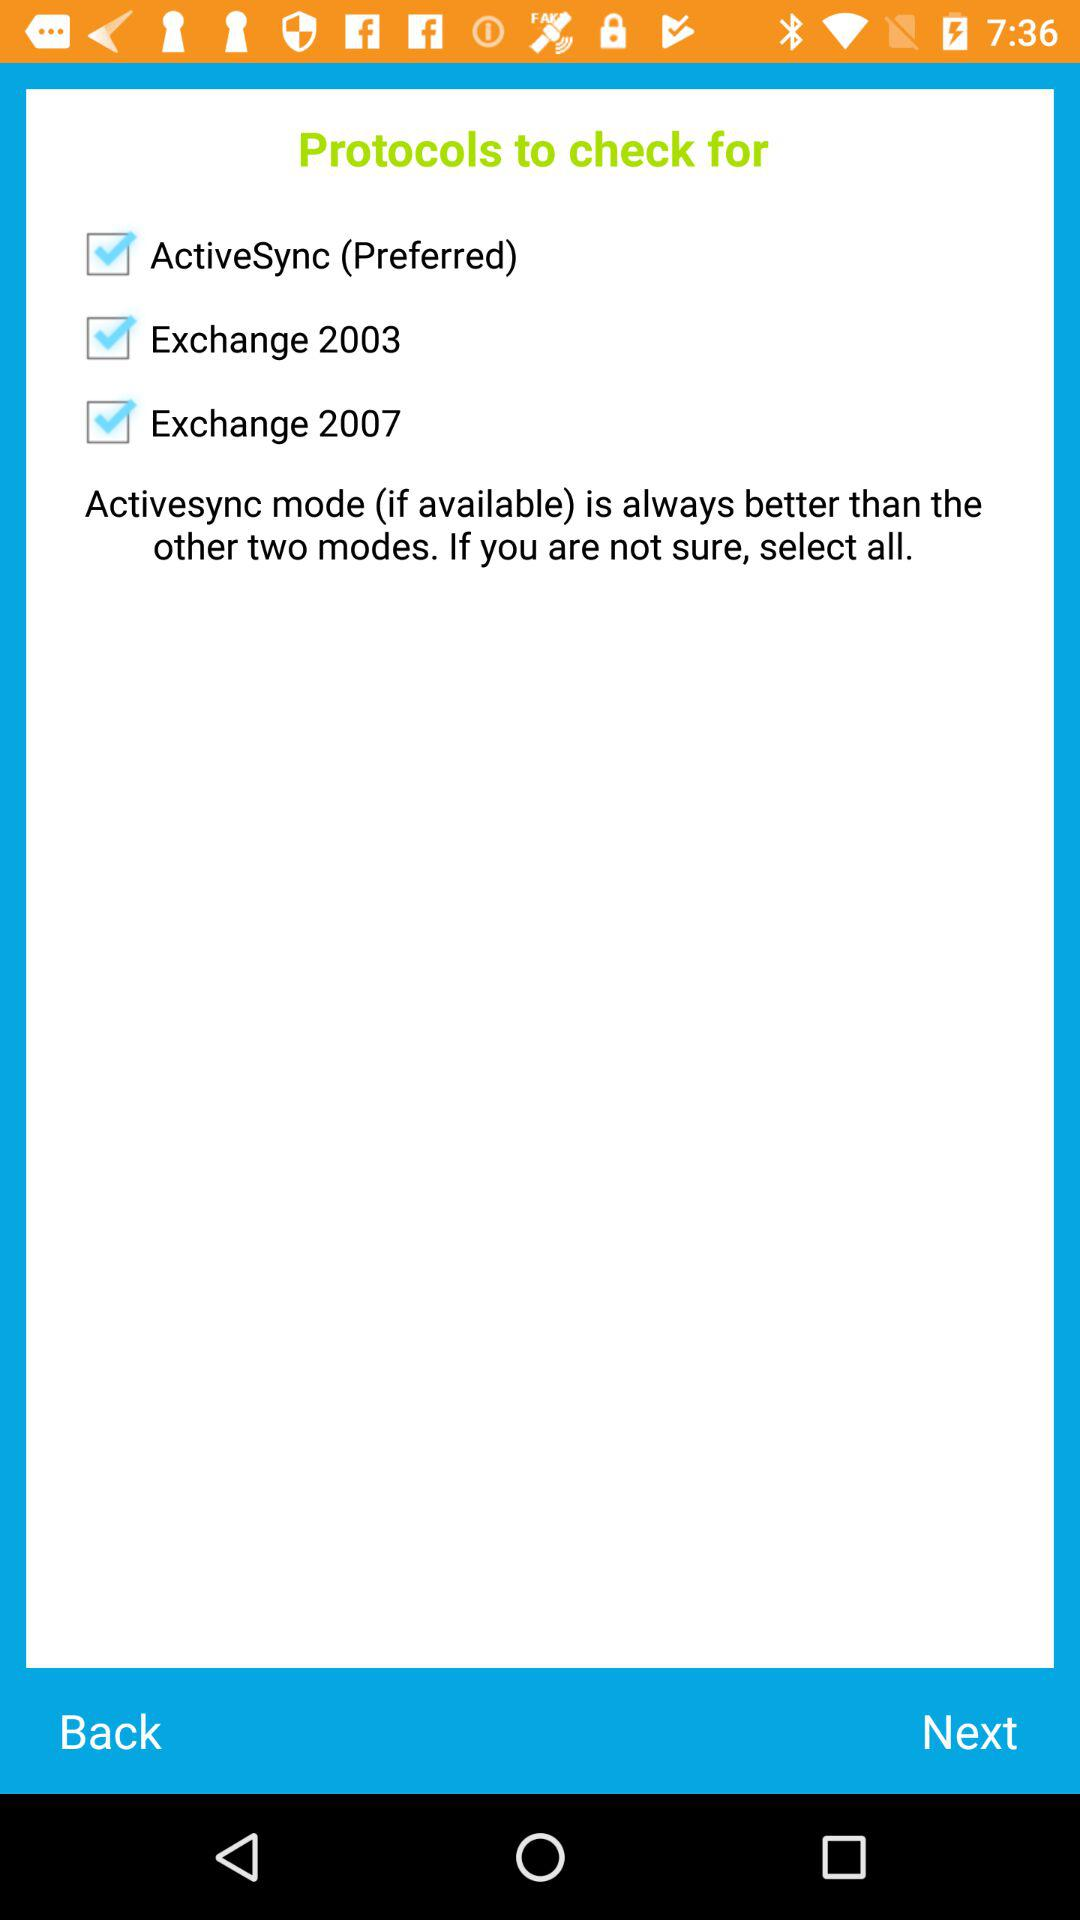How many protocols are there in total?
Answer the question using a single word or phrase. 3 